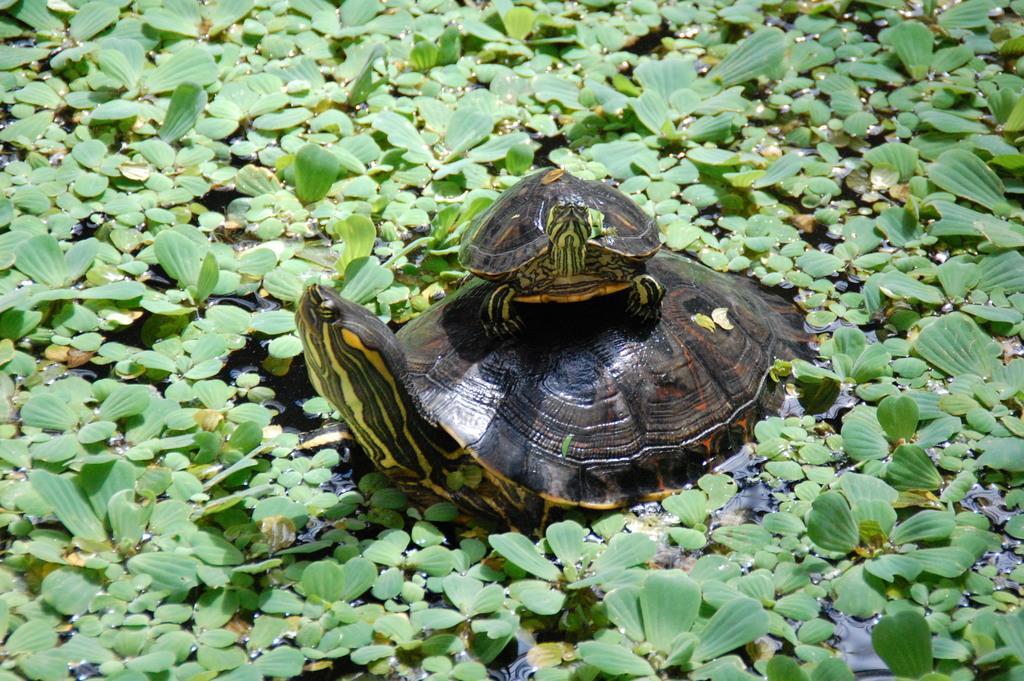Could you give a brief overview of what you see in this image? In this picture I can see a big turtle and a small turtle on it and few plants in the water. 